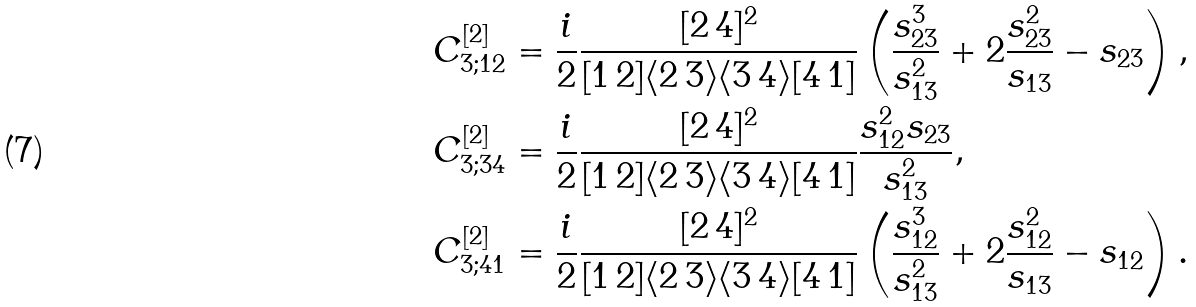Convert formula to latex. <formula><loc_0><loc_0><loc_500><loc_500>C _ { 3 ; 1 2 } ^ { [ 2 ] } & = \frac { i } { 2 } \frac { [ 2 \, 4 ] ^ { 2 } } { [ 1 \, 2 ] \langle 2 \, 3 \rangle \langle 3 \, 4 \rangle [ 4 \, 1 ] } \left ( \frac { s _ { 2 3 } ^ { 3 } } { s _ { 1 3 } ^ { 2 } } + 2 \frac { s _ { 2 3 } ^ { 2 } } { s _ { 1 3 } } - s _ { 2 3 } \right ) , \\ C _ { 3 ; 3 4 } ^ { [ 2 ] } & = \frac { i } { 2 } \frac { [ 2 \, 4 ] ^ { 2 } } { [ 1 \, 2 ] \langle 2 \, 3 \rangle \langle 3 \, 4 \rangle [ 4 \, 1 ] } \frac { s _ { 1 2 } ^ { 2 } s _ { 2 3 } } { s _ { 1 3 } ^ { 2 } } , \\ C _ { 3 ; 4 1 } ^ { [ 2 ] } & = \frac { i } { 2 } \frac { [ 2 \, 4 ] ^ { 2 } } { [ 1 \, 2 ] \langle 2 \, 3 \rangle \langle 3 \, 4 \rangle [ 4 \, 1 ] } \left ( \frac { s _ { 1 2 } ^ { 3 } } { s _ { 1 3 } ^ { 2 } } + 2 \frac { s _ { 1 2 } ^ { 2 } } { s _ { 1 3 } } - s _ { 1 2 } \right ) .</formula> 